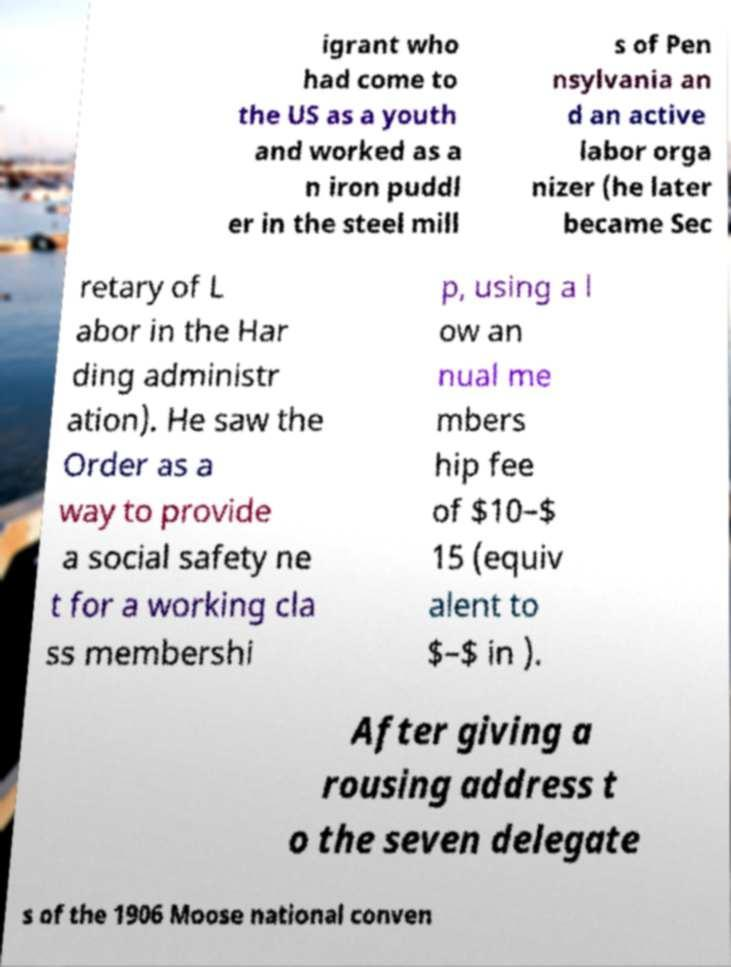Please identify and transcribe the text found in this image. igrant who had come to the US as a youth and worked as a n iron puddl er in the steel mill s of Pen nsylvania an d an active labor orga nizer (he later became Sec retary of L abor in the Har ding administr ation). He saw the Order as a way to provide a social safety ne t for a working cla ss membershi p, using a l ow an nual me mbers hip fee of $10–$ 15 (equiv alent to $–$ in ). After giving a rousing address t o the seven delegate s of the 1906 Moose national conven 